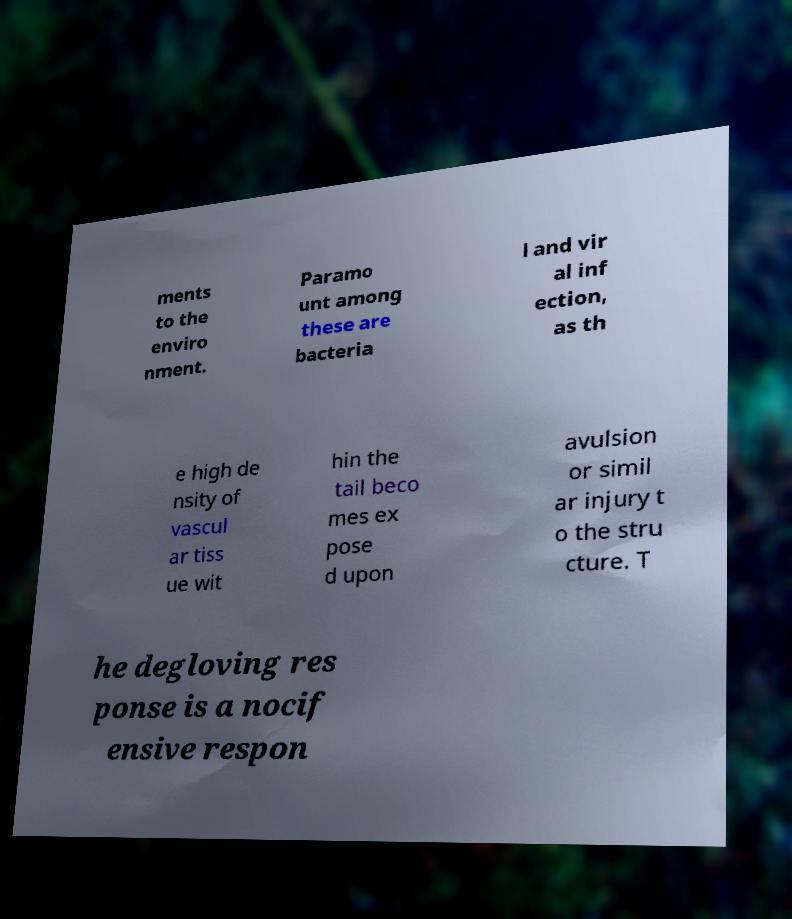What messages or text are displayed in this image? I need them in a readable, typed format. ments to the enviro nment. Paramo unt among these are bacteria l and vir al inf ection, as th e high de nsity of vascul ar tiss ue wit hin the tail beco mes ex pose d upon avulsion or simil ar injury t o the stru cture. T he degloving res ponse is a nocif ensive respon 